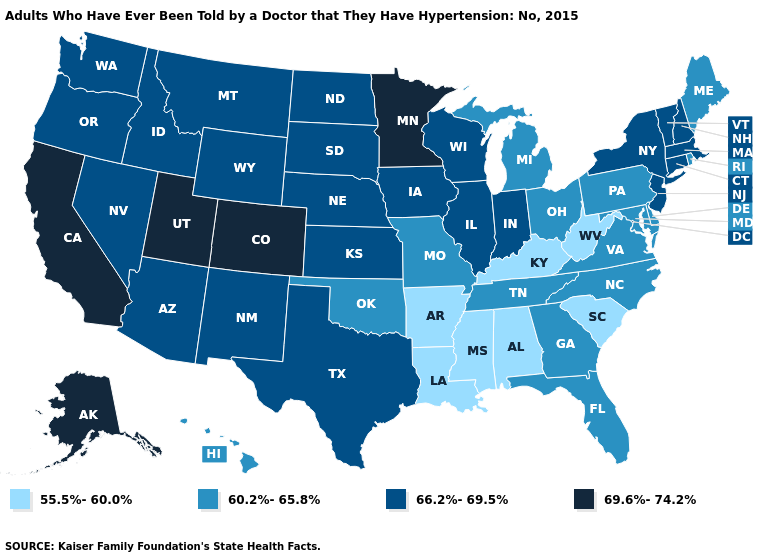Name the states that have a value in the range 55.5%-60.0%?
Concise answer only. Alabama, Arkansas, Kentucky, Louisiana, Mississippi, South Carolina, West Virginia. Does Florida have the same value as North Carolina?
Quick response, please. Yes. What is the value of New Hampshire?
Quick response, please. 66.2%-69.5%. Name the states that have a value in the range 69.6%-74.2%?
Concise answer only. Alaska, California, Colorado, Minnesota, Utah. Is the legend a continuous bar?
Short answer required. No. What is the highest value in the USA?
Answer briefly. 69.6%-74.2%. What is the value of Minnesota?
Write a very short answer. 69.6%-74.2%. What is the highest value in the USA?
Be succinct. 69.6%-74.2%. Does Minnesota have a higher value than California?
Be succinct. No. Name the states that have a value in the range 55.5%-60.0%?
Give a very brief answer. Alabama, Arkansas, Kentucky, Louisiana, Mississippi, South Carolina, West Virginia. What is the value of New Mexico?
Quick response, please. 66.2%-69.5%. What is the highest value in the Northeast ?
Give a very brief answer. 66.2%-69.5%. What is the value of Texas?
Be succinct. 66.2%-69.5%. What is the highest value in the South ?
Answer briefly. 66.2%-69.5%. Which states have the lowest value in the West?
Keep it brief. Hawaii. 